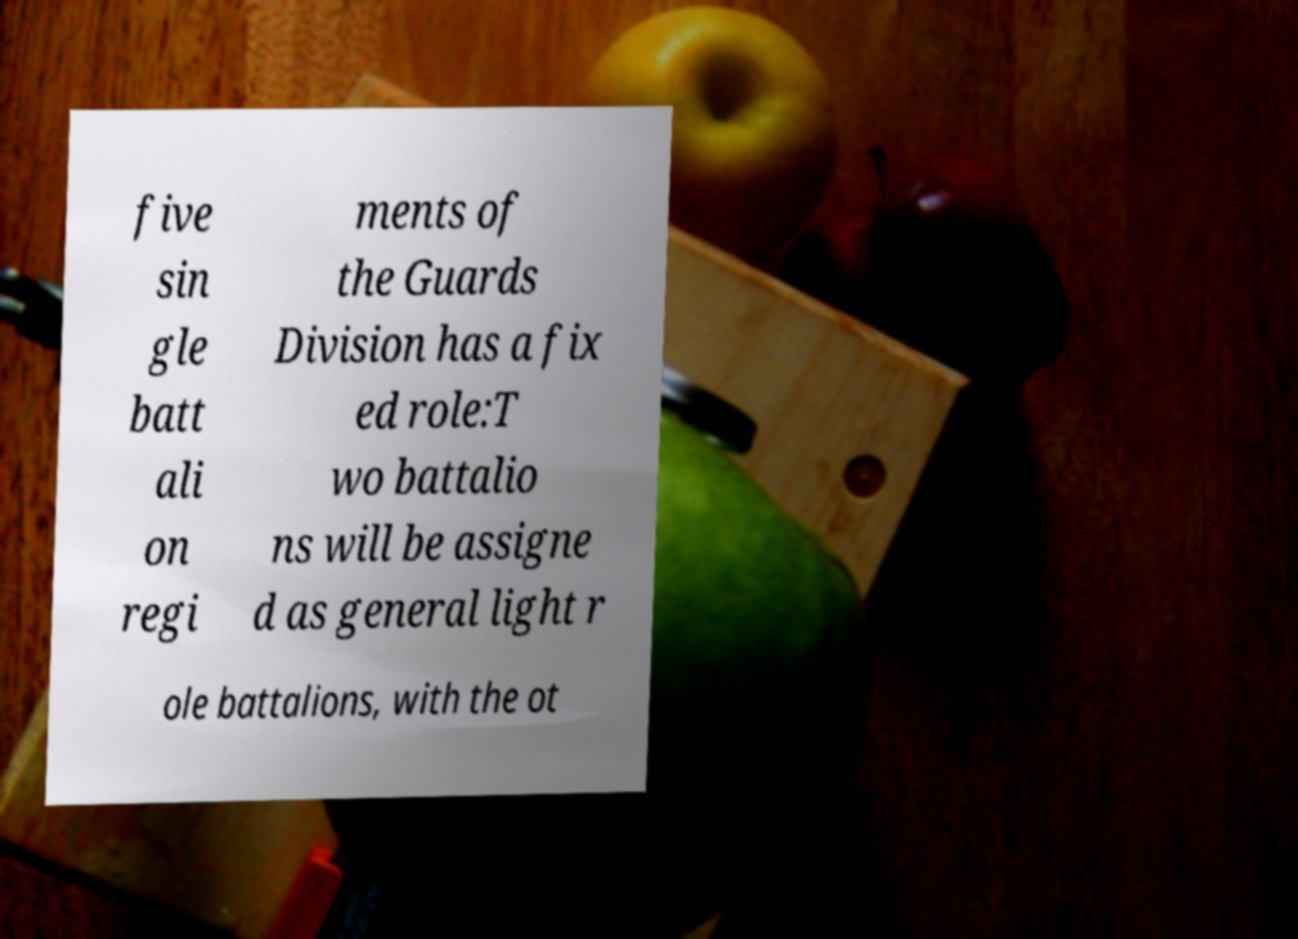There's text embedded in this image that I need extracted. Can you transcribe it verbatim? five sin gle batt ali on regi ments of the Guards Division has a fix ed role:T wo battalio ns will be assigne d as general light r ole battalions, with the ot 